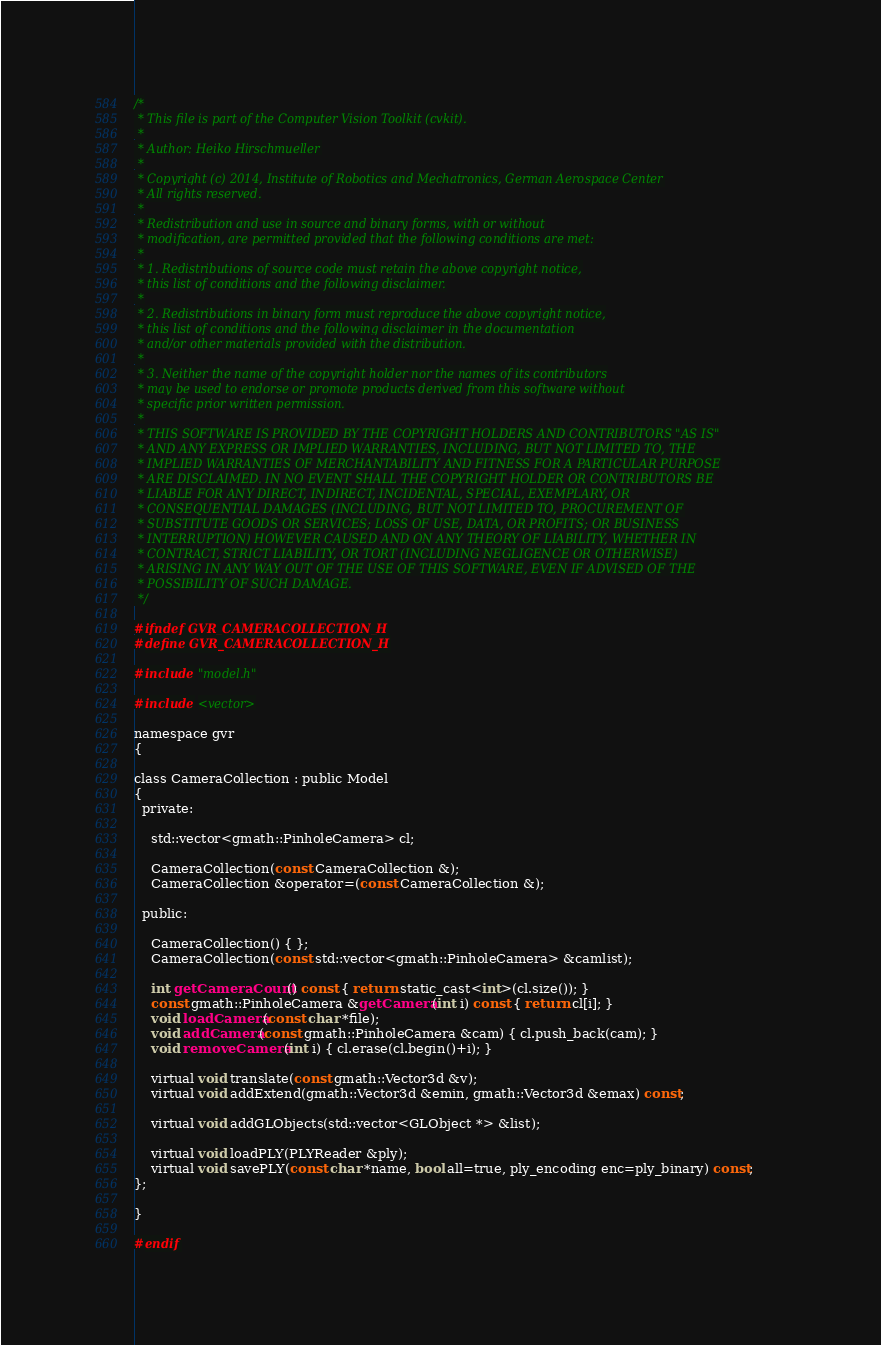<code> <loc_0><loc_0><loc_500><loc_500><_C_>/*
 * This file is part of the Computer Vision Toolkit (cvkit).
 *
 * Author: Heiko Hirschmueller
 *
 * Copyright (c) 2014, Institute of Robotics and Mechatronics, German Aerospace Center
 * All rights reserved.
 *
 * Redistribution and use in source and binary forms, with or without
 * modification, are permitted provided that the following conditions are met:
 *
 * 1. Redistributions of source code must retain the above copyright notice,
 * this list of conditions and the following disclaimer.
 *
 * 2. Redistributions in binary form must reproduce the above copyright notice,
 * this list of conditions and the following disclaimer in the documentation
 * and/or other materials provided with the distribution.
 *
 * 3. Neither the name of the copyright holder nor the names of its contributors
 * may be used to endorse or promote products derived from this software without
 * specific prior written permission.
 *
 * THIS SOFTWARE IS PROVIDED BY THE COPYRIGHT HOLDERS AND CONTRIBUTORS "AS IS"
 * AND ANY EXPRESS OR IMPLIED WARRANTIES, INCLUDING, BUT NOT LIMITED TO, THE
 * IMPLIED WARRANTIES OF MERCHANTABILITY AND FITNESS FOR A PARTICULAR PURPOSE
 * ARE DISCLAIMED. IN NO EVENT SHALL THE COPYRIGHT HOLDER OR CONTRIBUTORS BE
 * LIABLE FOR ANY DIRECT, INDIRECT, INCIDENTAL, SPECIAL, EXEMPLARY, OR
 * CONSEQUENTIAL DAMAGES (INCLUDING, BUT NOT LIMITED TO, PROCUREMENT OF
 * SUBSTITUTE GOODS OR SERVICES; LOSS OF USE, DATA, OR PROFITS; OR BUSINESS
 * INTERRUPTION) HOWEVER CAUSED AND ON ANY THEORY OF LIABILITY, WHETHER IN
 * CONTRACT, STRICT LIABILITY, OR TORT (INCLUDING NEGLIGENCE OR OTHERWISE)
 * ARISING IN ANY WAY OUT OF THE USE OF THIS SOFTWARE, EVEN IF ADVISED OF THE
 * POSSIBILITY OF SUCH DAMAGE.
 */

#ifndef GVR_CAMERACOLLECTION_H
#define GVR_CAMERACOLLECTION_H

#include "model.h"

#include <vector>

namespace gvr
{

class CameraCollection : public Model
{
  private:

    std::vector<gmath::PinholeCamera> cl;

    CameraCollection(const CameraCollection &);
    CameraCollection &operator=(const CameraCollection &);

  public:

    CameraCollection() { };
    CameraCollection(const std::vector<gmath::PinholeCamera> &camlist);

    int getCameraCount() const { return static_cast<int>(cl.size()); }
    const gmath::PinholeCamera &getCamera(int i) const { return cl[i]; }
    void loadCamera(const char *file);
    void addCamera(const gmath::PinholeCamera &cam) { cl.push_back(cam); }
    void removeCamera(int i) { cl.erase(cl.begin()+i); }

    virtual void translate(const gmath::Vector3d &v);
    virtual void addExtend(gmath::Vector3d &emin, gmath::Vector3d &emax) const;

    virtual void addGLObjects(std::vector<GLObject *> &list);

    virtual void loadPLY(PLYReader &ply);
    virtual void savePLY(const char *name, bool all=true, ply_encoding enc=ply_binary) const;
};

}

#endif
</code> 